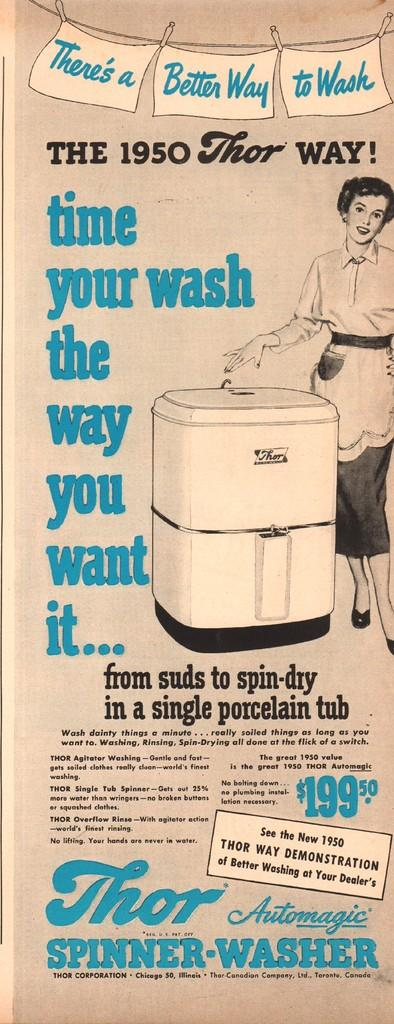Provide a one-sentence caption for the provided image. An ad for a Thor Automagic Spinner Washer selling for $199.50. 